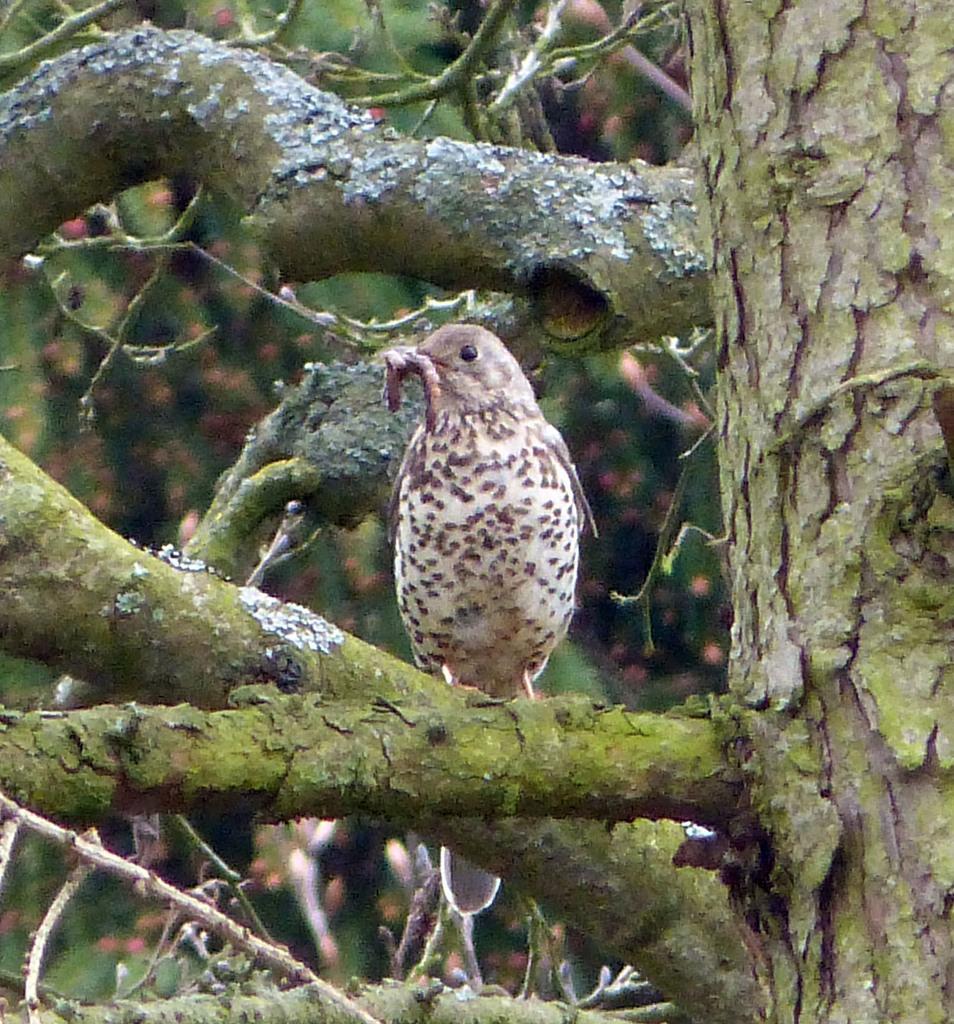How would you summarize this image in a sentence or two? In this image I can see a tree trunk, few branches and on the one branch I can see a bird. I can also see this image is little bit blurry in the background. 